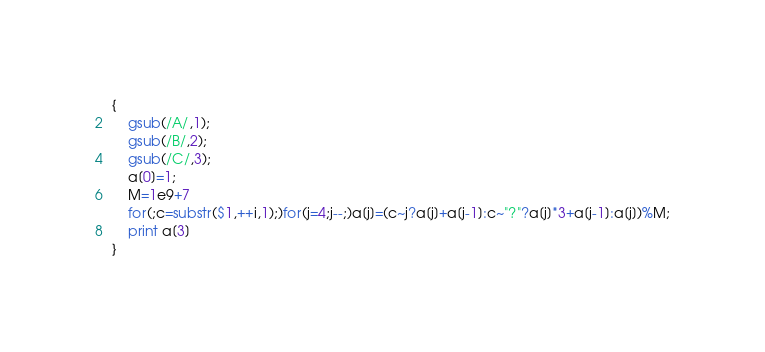Convert code to text. <code><loc_0><loc_0><loc_500><loc_500><_Awk_>{
	gsub(/A/,1);
	gsub(/B/,2);
	gsub(/C/,3);
	a[0]=1;
	M=1e9+7
	for(;c=substr($1,++i,1);)for(j=4;j--;)a[j]=(c~j?a[j]+a[j-1]:c~"?"?a[j]*3+a[j-1]:a[j])%M;
	print a[3]
}</code> 